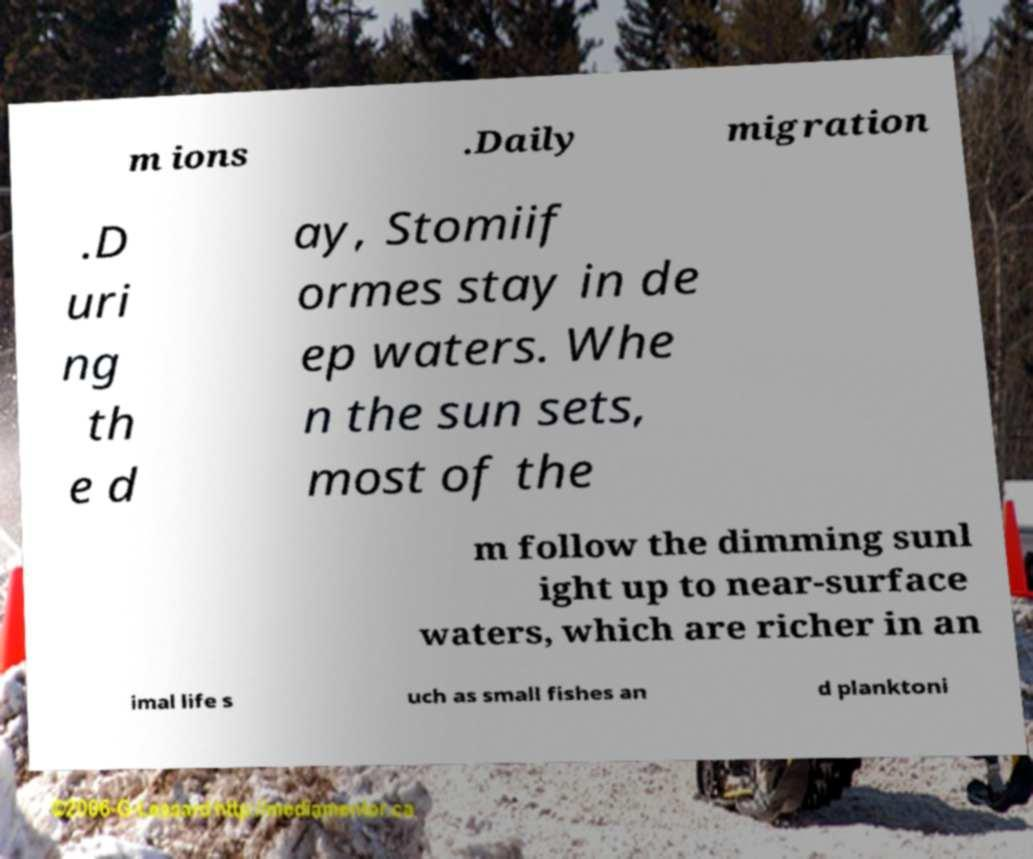Could you assist in decoding the text presented in this image and type it out clearly? m ions .Daily migration .D uri ng th e d ay, Stomiif ormes stay in de ep waters. Whe n the sun sets, most of the m follow the dimming sunl ight up to near-surface waters, which are richer in an imal life s uch as small fishes an d planktoni 